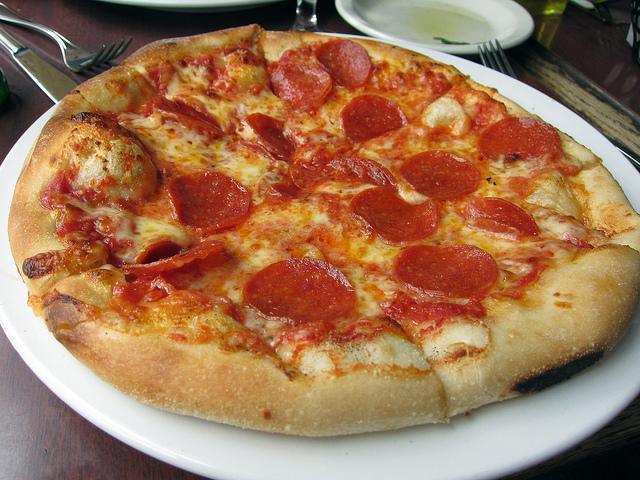How many slices do these pizza carrying?
Give a very brief answer. 6. How many dining tables are in the picture?
Give a very brief answer. 2. How many of these people are female?
Give a very brief answer. 0. 